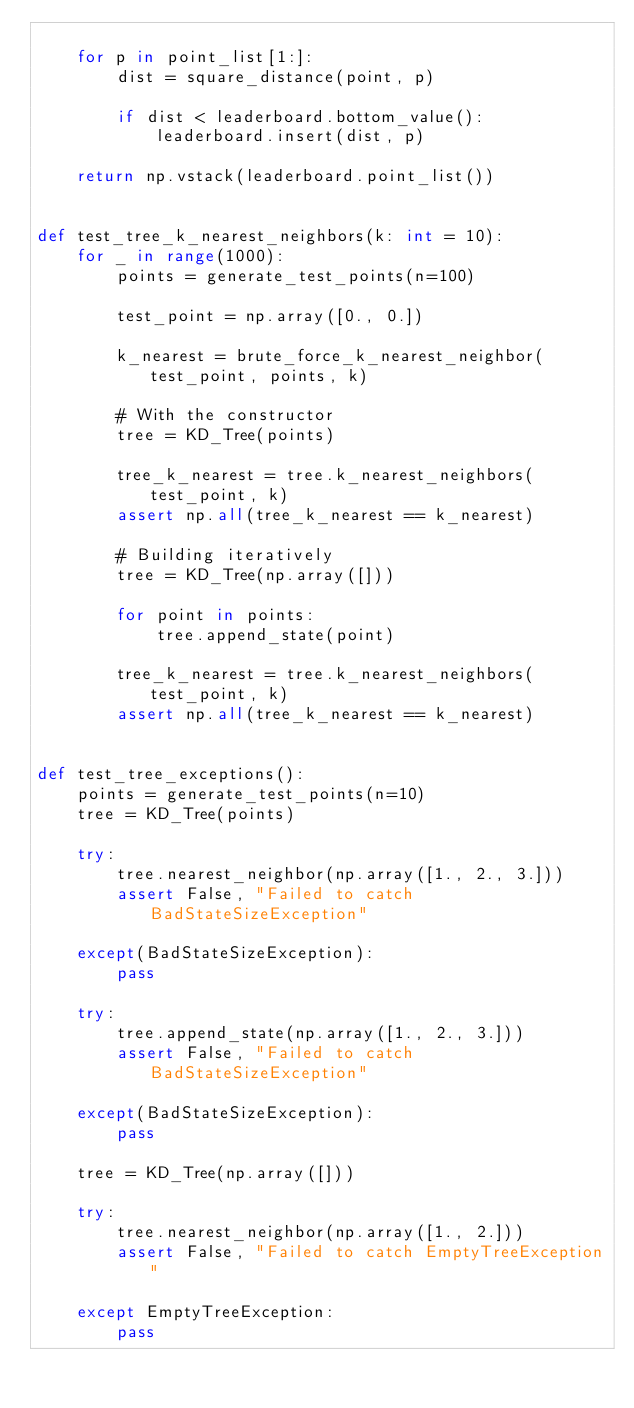Convert code to text. <code><loc_0><loc_0><loc_500><loc_500><_Python_>
    for p in point_list[1:]:
        dist = square_distance(point, p)

        if dist < leaderboard.bottom_value():
            leaderboard.insert(dist, p)

    return np.vstack(leaderboard.point_list())


def test_tree_k_nearest_neighbors(k: int = 10):
    for _ in range(1000):
        points = generate_test_points(n=100)

        test_point = np.array([0., 0.])

        k_nearest = brute_force_k_nearest_neighbor(test_point, points, k)

        # With the constructor
        tree = KD_Tree(points)

        tree_k_nearest = tree.k_nearest_neighbors(test_point, k)
        assert np.all(tree_k_nearest == k_nearest)

        # Building iteratively
        tree = KD_Tree(np.array([]))

        for point in points:
            tree.append_state(point)

        tree_k_nearest = tree.k_nearest_neighbors(test_point, k)
        assert np.all(tree_k_nearest == k_nearest)


def test_tree_exceptions():
    points = generate_test_points(n=10)
    tree = KD_Tree(points)

    try:
        tree.nearest_neighbor(np.array([1., 2., 3.]))
        assert False, "Failed to catch BadStateSizeException"

    except(BadStateSizeException):
        pass

    try:
        tree.append_state(np.array([1., 2., 3.]))
        assert False, "Failed to catch BadStateSizeException"

    except(BadStateSizeException):
        pass

    tree = KD_Tree(np.array([]))

    try:
        tree.nearest_neighbor(np.array([1., 2.]))
        assert False, "Failed to catch EmptyTreeException"

    except EmptyTreeException:
        pass
</code> 